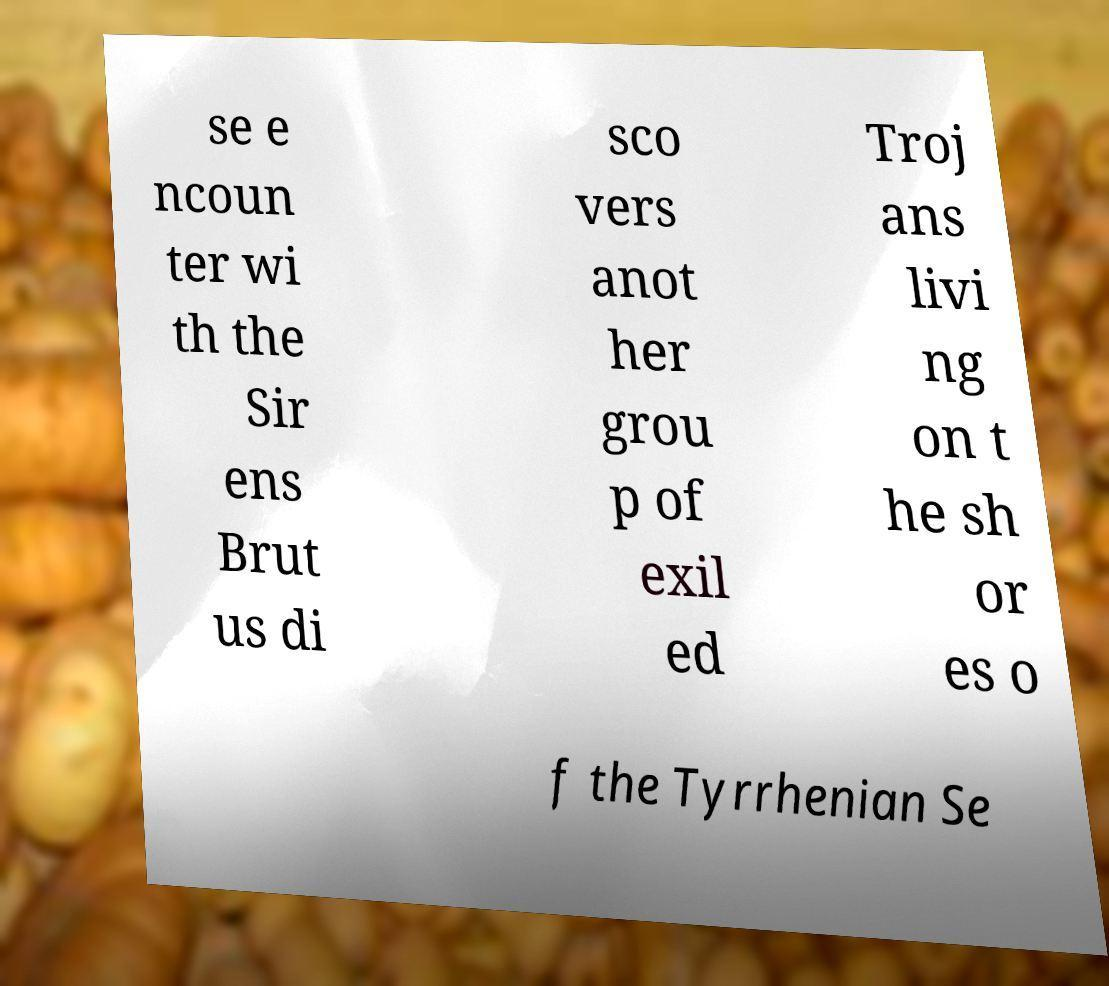I need the written content from this picture converted into text. Can you do that? se e ncoun ter wi th the Sir ens Brut us di sco vers anot her grou p of exil ed Troj ans livi ng on t he sh or es o f the Tyrrhenian Se 